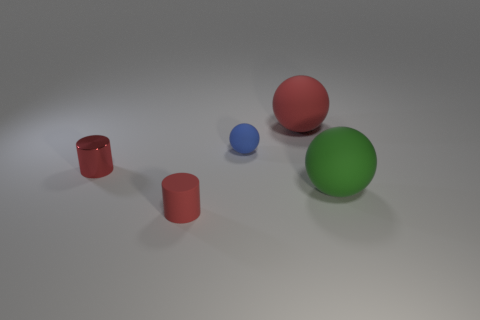Add 3 small rubber things. How many objects exist? 8 Subtract all spheres. How many objects are left? 2 Add 2 small blue matte spheres. How many small blue matte spheres exist? 3 Subtract 0 gray cylinders. How many objects are left? 5 Subtract all small brown rubber balls. Subtract all large matte things. How many objects are left? 3 Add 2 big green spheres. How many big green spheres are left? 3 